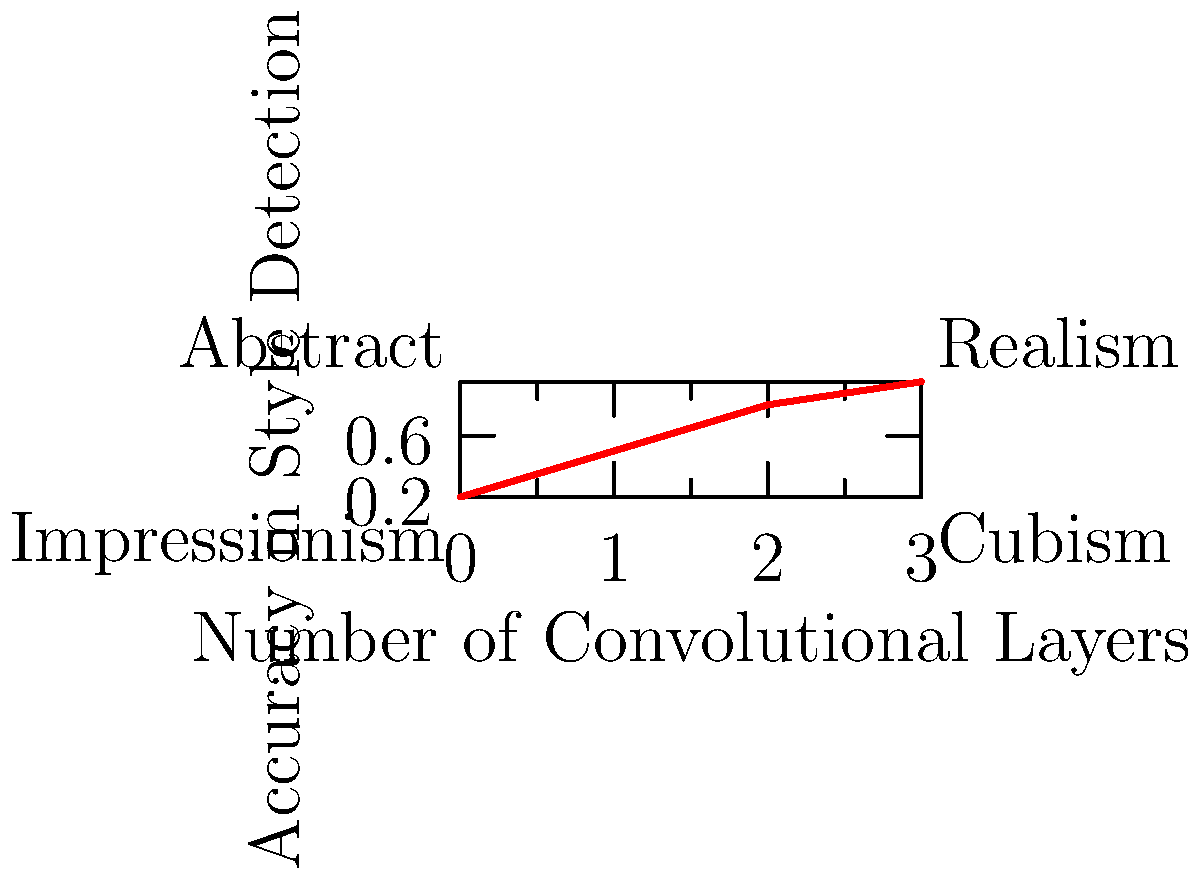In a Convolutional Neural Network (CNN) designed to detect different art styles from images of paintings, how does the accuracy of style detection change as the number of convolutional layers increases? Which art style seems to be the most challenging to detect accurately? To answer this question, we need to analyze the graph:

1. The x-axis represents the number of convolutional layers in the CNN.
2. The y-axis represents the accuracy in style detection.
3. The red line shows the relationship between the number of layers and accuracy.

Step-by-step analysis:
1. As the number of convolutional layers increases from 0 to 3, we see a consistent increase in accuracy.
2. The slope of the line is steepest between 0 and 1 layers, indicating the most significant improvement in accuracy occurs with the addition of the first layer.
3. The rate of improvement decreases slightly as more layers are added, shown by the gradually decreasing slope.
4. At 3 layers, the accuracy reaches its highest point at about 0.95 or 95%.

To determine which art style is most challenging to detect:
1. The graph labels four art styles in different corners.
2. Impressionism is placed at the bottom-left, suggesting it's detected with lower accuracy and fewer layers.
3. Cubism and Abstract are in the middle positions.
4. Realism is at the top-right, indicating it's detected with high accuracy and more layers.

Therefore, Impressionism appears to be the most challenging style to detect accurately, as it's associated with lower accuracy even with fewer layers.
Answer: Accuracy increases with more layers; Impressionism is most challenging to detect. 